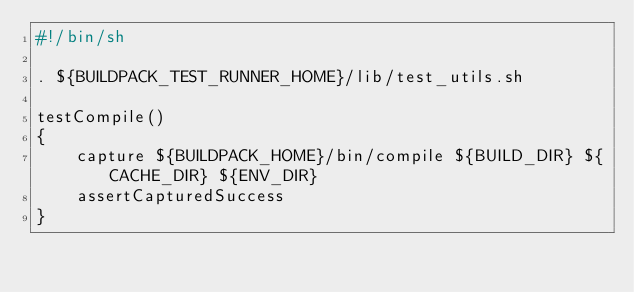<code> <loc_0><loc_0><loc_500><loc_500><_Bash_>#!/bin/sh

. ${BUILDPACK_TEST_RUNNER_HOME}/lib/test_utils.sh

testCompile()
{
    capture ${BUILDPACK_HOME}/bin/compile ${BUILD_DIR} ${CACHE_DIR} ${ENV_DIR}
    assertCapturedSuccess
}
</code> 